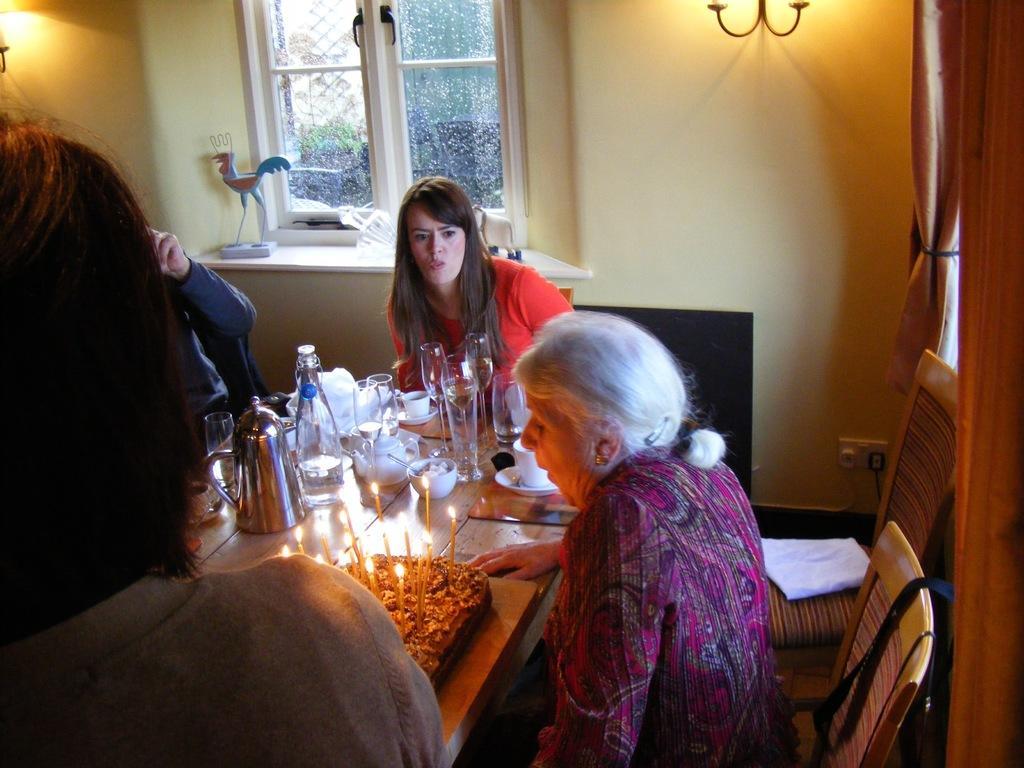Can you describe this image briefly? A lady wearing pink dress is sitting on chair is blowing candles. There is another lady wearing red t shirt is sitting on a chair. And there is a table in front of them. On the table there is a cake, cup, saucer, bowl, glasses, bottle and a kettle. There are another chair. In the background there is a wall, window. Near to the window there are some toys. There are lights in the wall. 